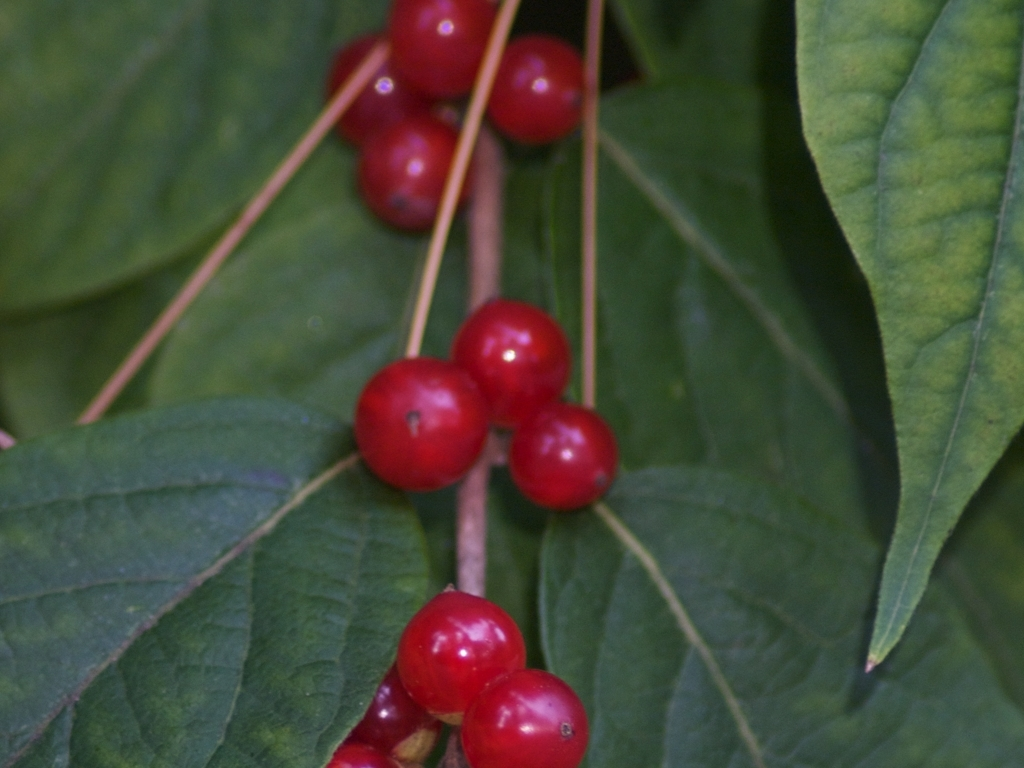Is there any visible noise in the image? After inspecting the image, I can confirm that it is quite clear, without any noticeable noise or graininess. The berries and leaves are depicted with a good level of detail, and the image quality does not seem to be compromised by any visual distortions typically associated with noise. 